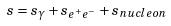Convert formula to latex. <formula><loc_0><loc_0><loc_500><loc_500>s = s _ { \gamma } + s _ { e ^ { + } e ^ { - } } + s _ { n u c l e o n }</formula> 